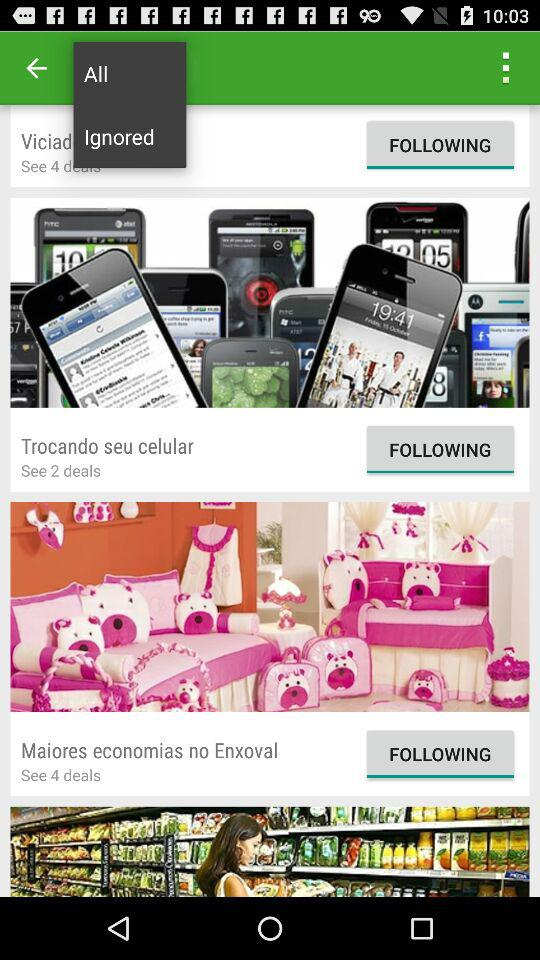What item has 2 deals? The item that has 2 deals is "Trocando seu celular". 